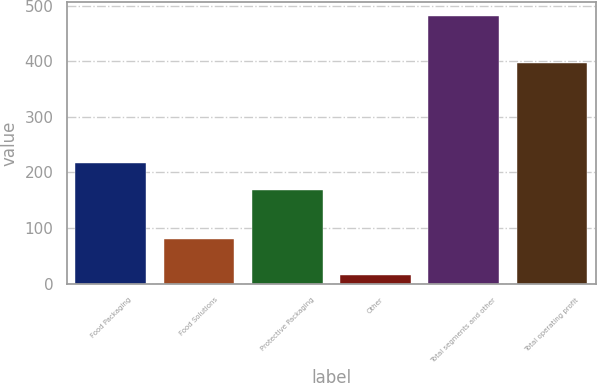Convert chart to OTSL. <chart><loc_0><loc_0><loc_500><loc_500><bar_chart><fcel>Food Packaging<fcel>Food Solutions<fcel>Protective Packaging<fcel>Other<fcel>Total segments and other<fcel>Total operating profit<nl><fcel>217.5<fcel>80<fcel>169.1<fcel>15<fcel>481.6<fcel>396.5<nl></chart> 